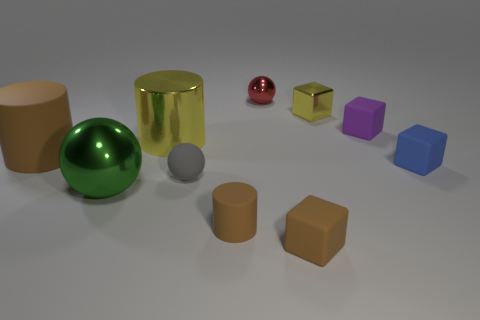There is a small brown object that is the same shape as the big yellow object; what material is it?
Make the answer very short. Rubber. What material is the yellow object that is right of the small red metal ball?
Ensure brevity in your answer.  Metal. Is the number of yellow metal objects greater than the number of blue matte blocks?
Make the answer very short. Yes. Do the yellow thing that is to the left of the tiny gray ball and the big brown object have the same shape?
Your response must be concise. Yes. How many rubber things are behind the matte sphere and on the right side of the big green sphere?
Offer a very short reply. 2. What number of yellow things are the same shape as the green shiny thing?
Make the answer very short. 0. There is a big cylinder that is on the left side of the ball that is on the left side of the big yellow metal cylinder; what is its color?
Provide a short and direct response. Brown. Do the small gray matte object and the metallic object that is in front of the gray matte thing have the same shape?
Make the answer very short. Yes. There is a yellow thing on the left side of the small rubber cube that is in front of the blue object that is on the right side of the tiny red shiny ball; what is it made of?
Offer a very short reply. Metal. Is there a yellow matte ball that has the same size as the blue matte cube?
Keep it short and to the point. No. 